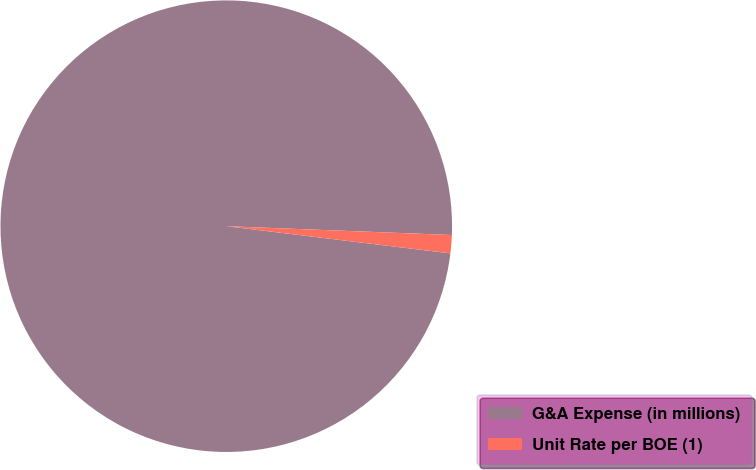<chart> <loc_0><loc_0><loc_500><loc_500><pie_chart><fcel>G&A Expense (in millions)<fcel>Unit Rate per BOE (1)<nl><fcel>98.7%<fcel>1.3%<nl></chart> 